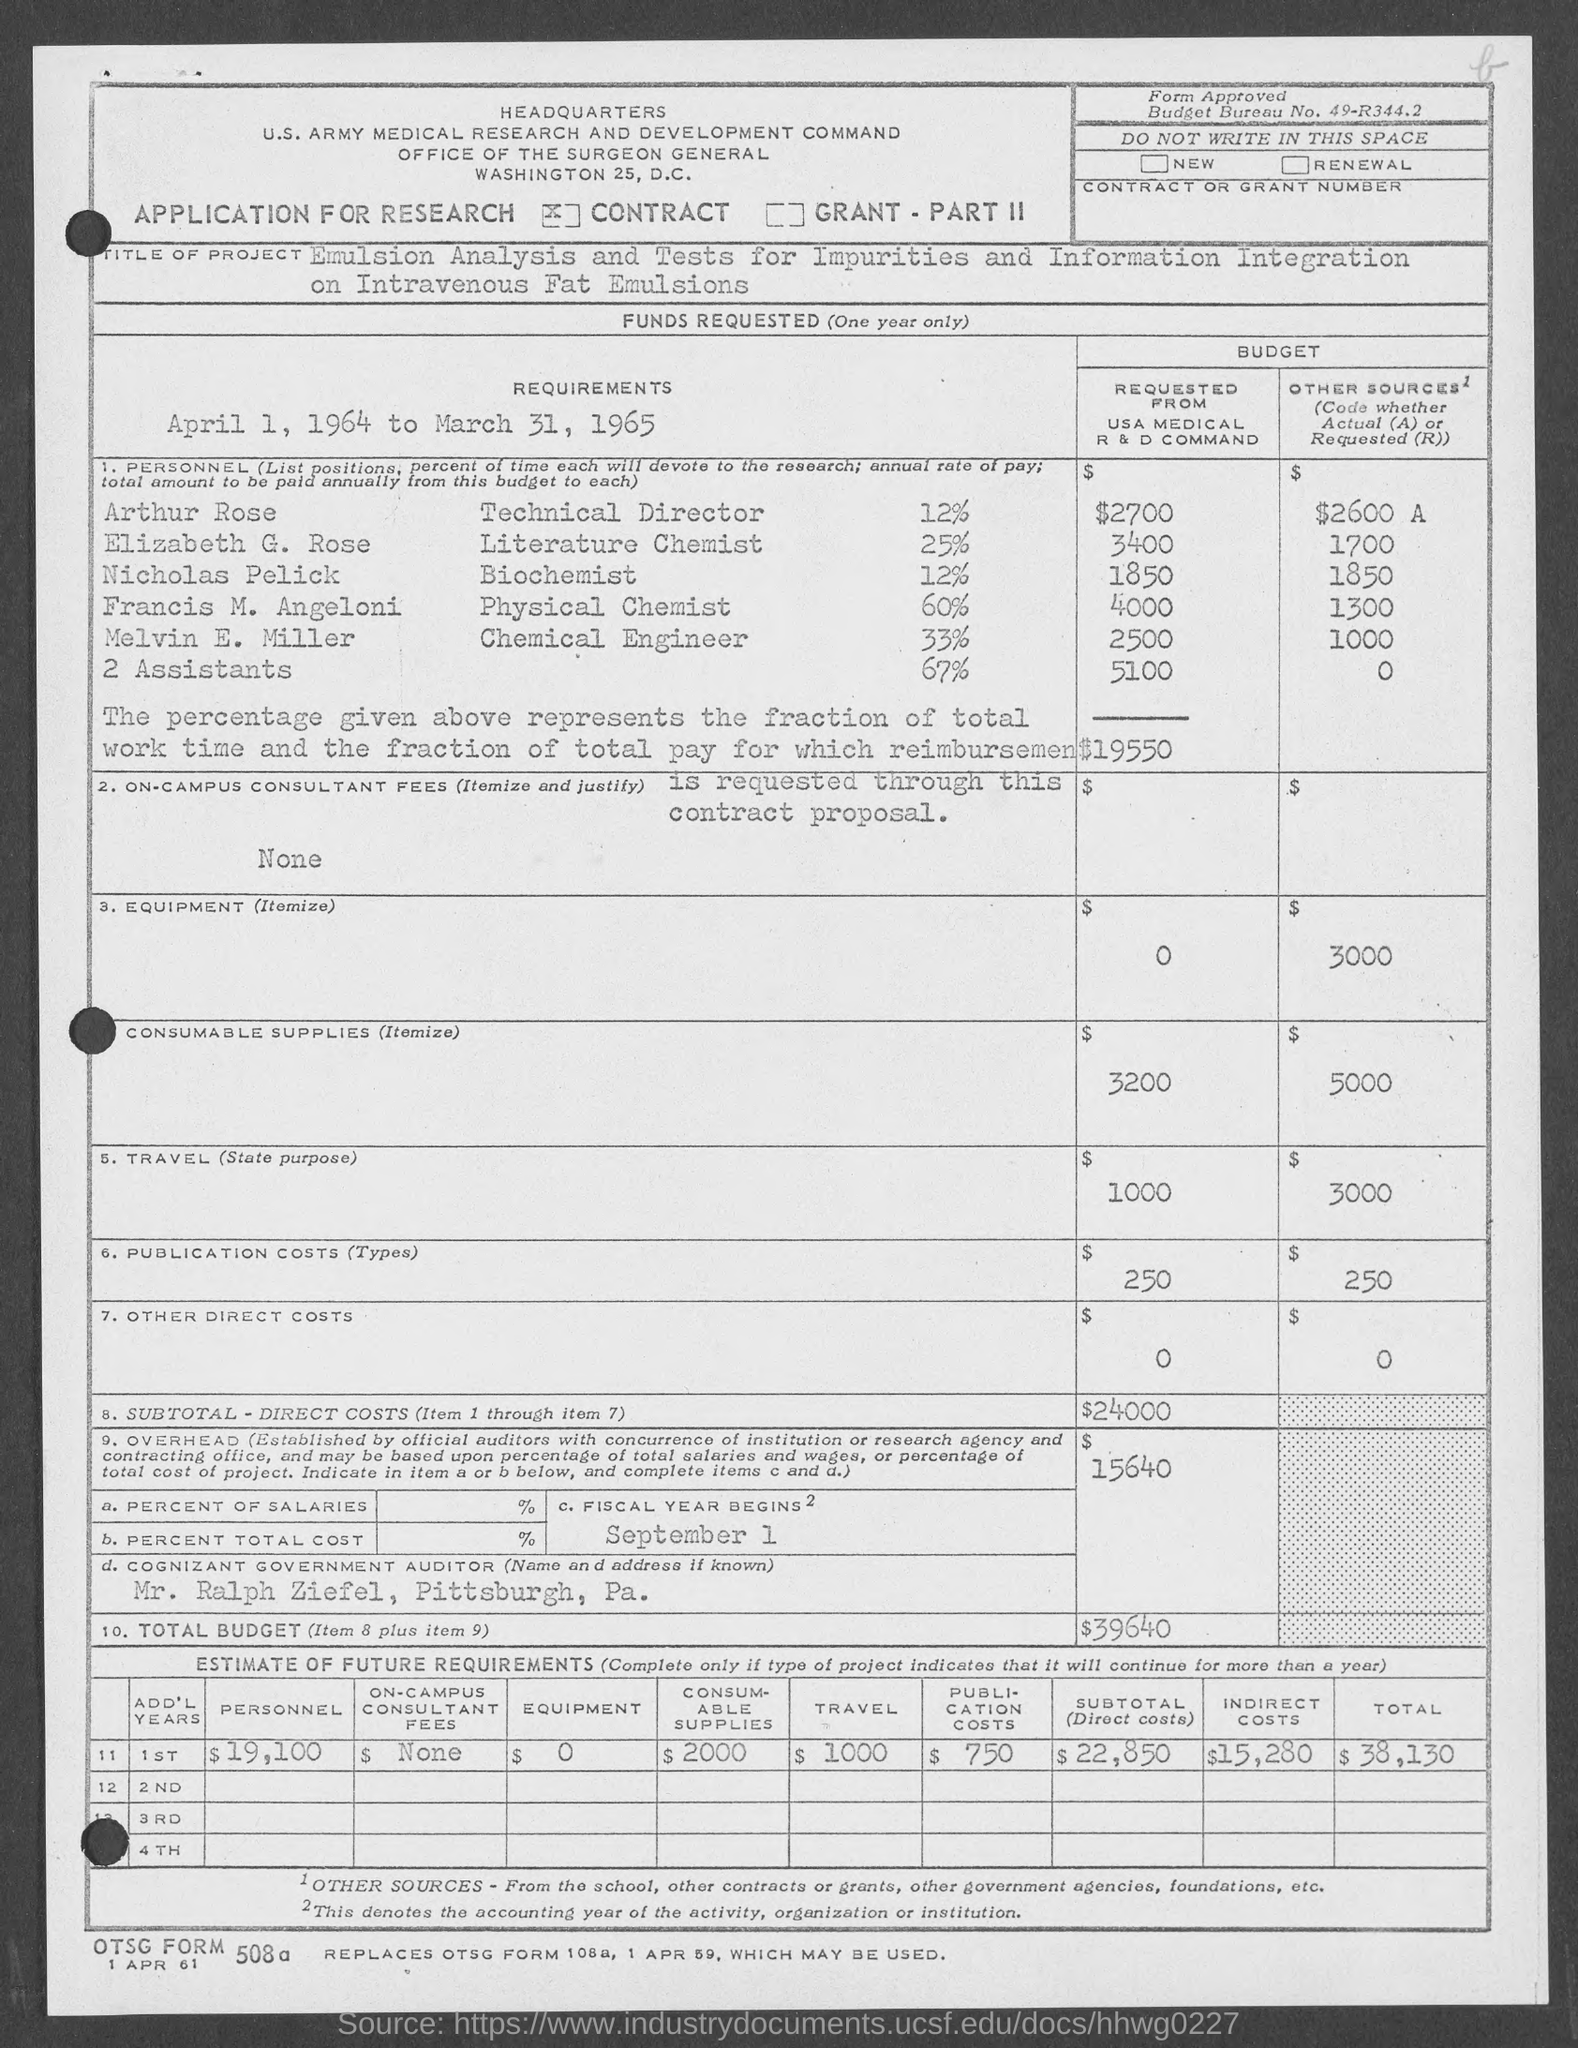Mention a couple of crucial points in this snapshot. The total budget is 39,640. The fiscal year begins on September 1st. The request for budget from the USA Medical R&D Command by Arthur Rose is 2700. The budget requested from the USA Medical R & D Command by Elizabeth G. Rose is 3400. The United States Army Medical Research and Development Command has requested a budget of $2,500 from Melvin E. Miller for a specific project. 